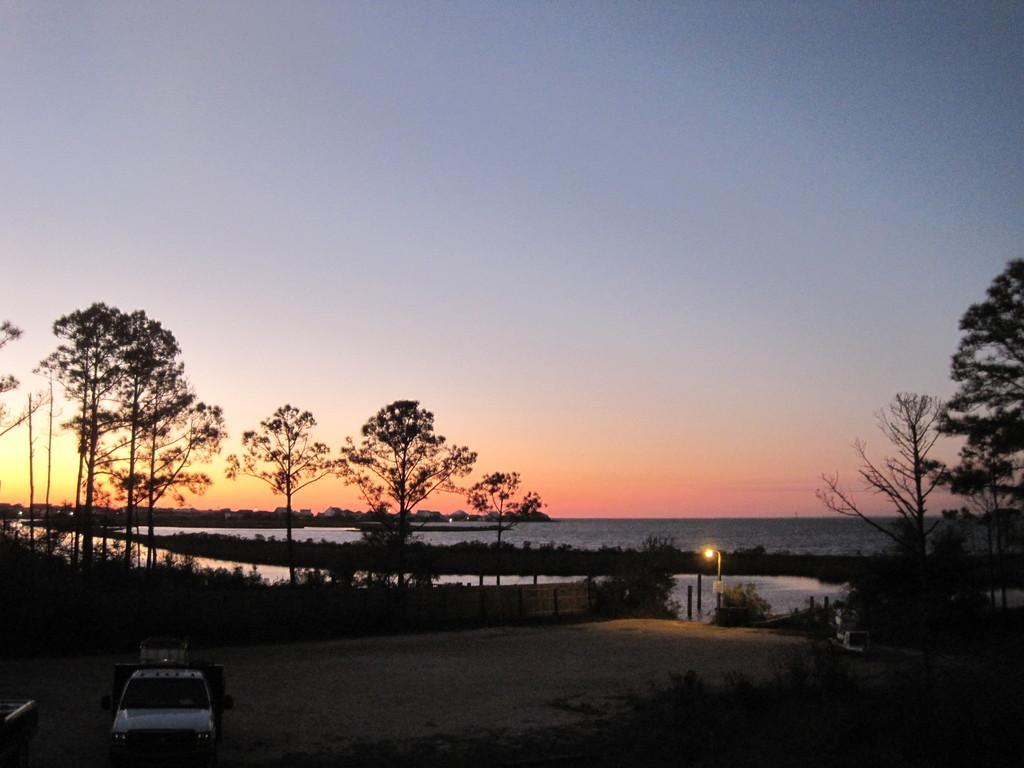Please provide a concise description of this image. In this picture I can see trees, plants and I can see water and a vehicle and looks like few buildings in the back and I can see blue sky. 